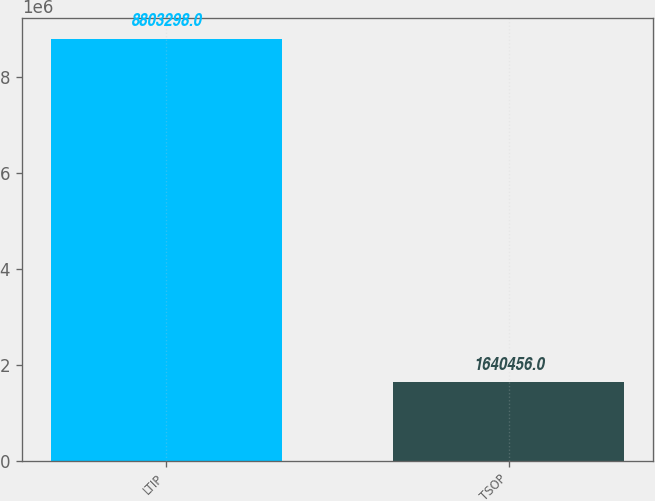Convert chart to OTSL. <chart><loc_0><loc_0><loc_500><loc_500><bar_chart><fcel>LTIP<fcel>TSOP<nl><fcel>8.8033e+06<fcel>1.64046e+06<nl></chart> 